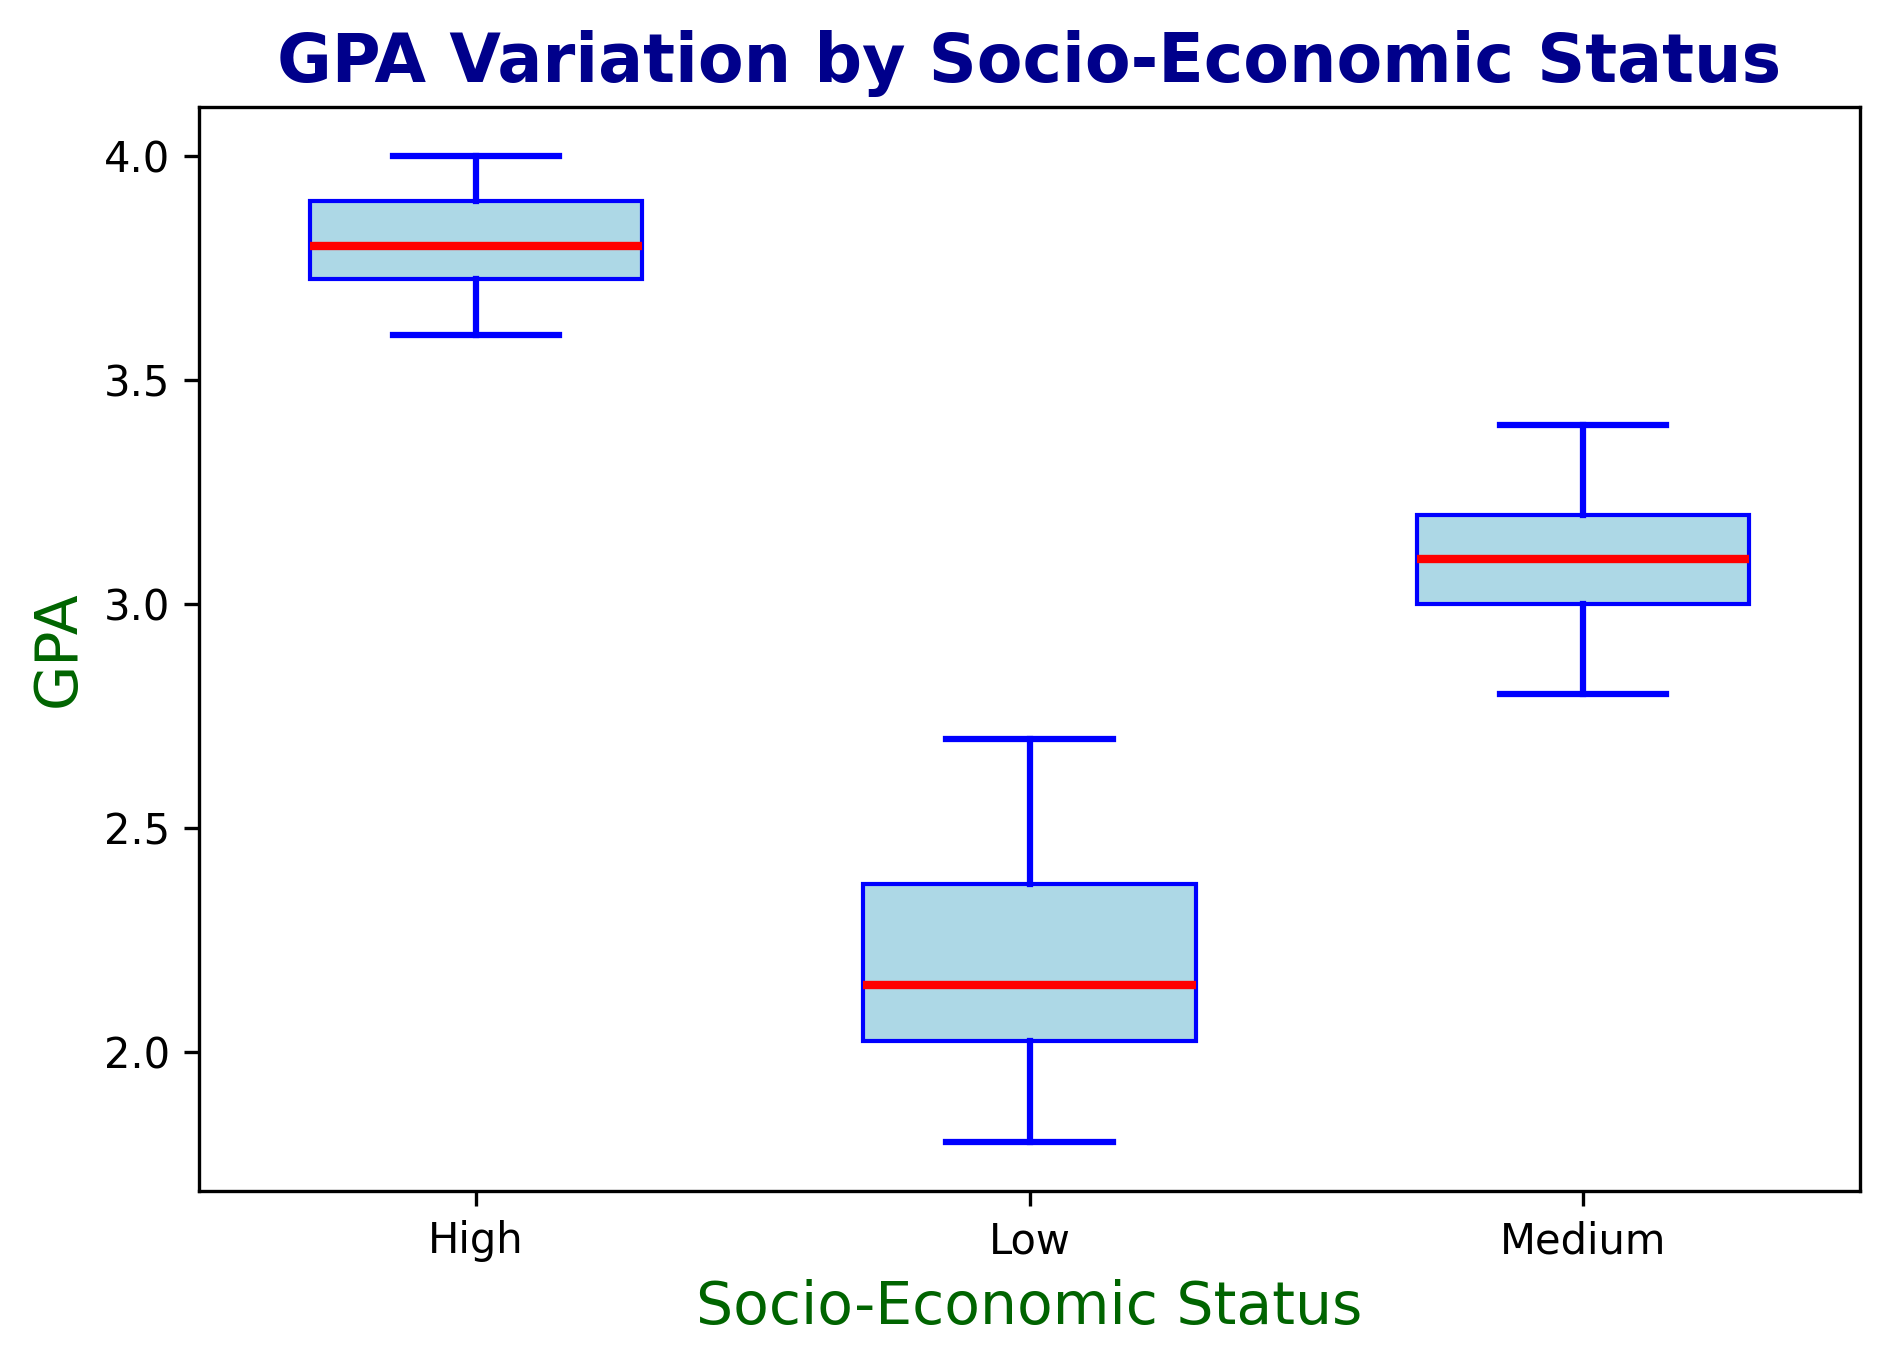Which socio-economic group has the highest median GPA? The median GPA is the middle value in each group's GPA distribution, indicated by the red line in the box plot. The group with the highest red line is the group with the highest median GPA.
Answer: High How much higher is the median GPA of the High socio-economic group compared to the Low socio-economic group? Identify the median GPAs for the High and Low groups from the red lines in the box plot and subtract the median of the Low group from the median of the High group.
Answer: 1.7 Which socio-economic group has the smallest range of GPAs? The range for each group is represented by the distance between the bottom and top whiskers in the box plot. The group with the smallest distance has the smallest range.
Answer: High What is the interquartile range (IQR) of the Medium socio-economic group? The IQR is the range between the first quartile (bottom edge of the box) and the third quartile (top edge of the box). Measure this vertical distance for the Medium group.
Answer: 0.6 Compare the variability in GPA between the Low and High socio-economic groups. Which group shows more variability? The variability can be inferred from the length of the whiskers and the height of the box. Larger whiskers and a taller box indicate more variability.
Answer: Low What can you determine about the outliers in the dataset? Outliers, if present, are shown as individual points outside the whiskers. Identify which box plots, if any, have such points.
Answer: No outliers Which socio-economic group has the highest third quartile (75th percentile) GPA? The third quartile is the top edge of each box in the box plot. The group with the highest top edge has the highest third quartile GPA.
Answer: High How does the median GPA of the Medium socio-economic group compare to the first quartile GPA of the High socio-economic group? Compare the red line in the Medium group's box plot to the bottom edge of the box in the High group's box plot.
Answer: Median of Medium is higher What is the approximate GPA range covered by the interquartile range for the Low socio-economic group? The interquartile range is the height of the box, covering the middle 50% of data. Measure the GPA values at the bottom and top edges of the box for the Low group.
Answer: 0.5 How does the median GPA of the Low socio-economic group compare to the GPA values of the other groups? Check the red line in the Low group and see how it compares with the red lines (medians) of the other groups. This will show the relative standing of the Low group's median GPA.
Answer: Lower than Medium and High 